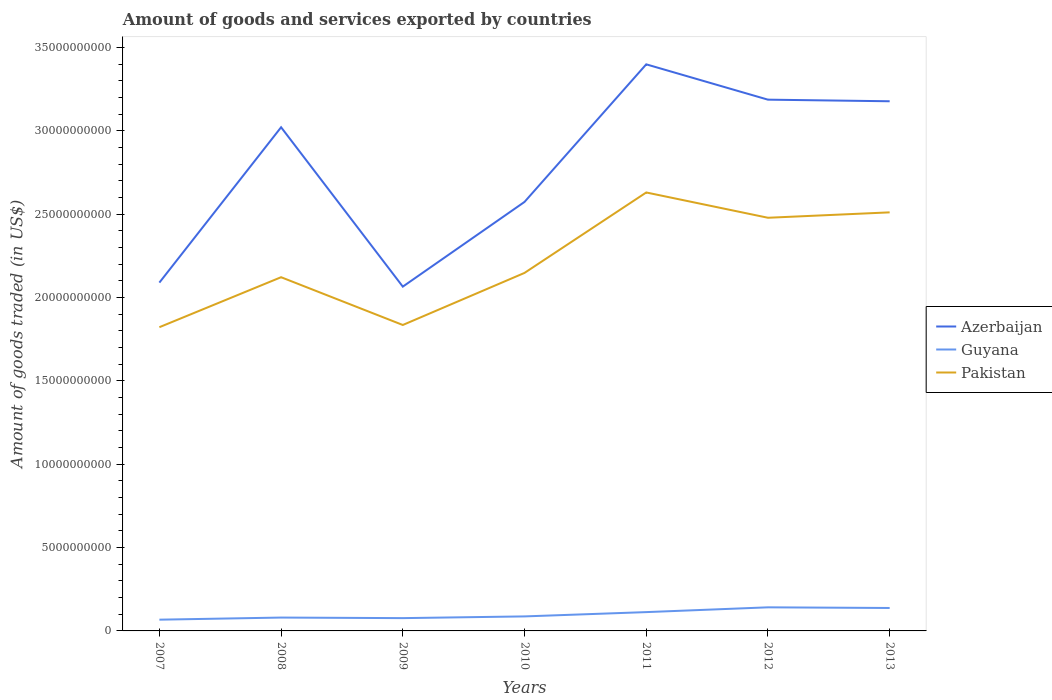Across all years, what is the maximum total amount of goods and services exported in Guyana?
Offer a very short reply. 6.75e+08. What is the total total amount of goods and services exported in Azerbaijan in the graph?
Offer a very short reply. -1.33e+1. What is the difference between the highest and the second highest total amount of goods and services exported in Azerbaijan?
Your answer should be compact. 1.33e+1. How many lines are there?
Keep it short and to the point. 3. What is the difference between two consecutive major ticks on the Y-axis?
Your answer should be very brief. 5.00e+09. Does the graph contain any zero values?
Keep it short and to the point. No. How many legend labels are there?
Your answer should be compact. 3. How are the legend labels stacked?
Your answer should be very brief. Vertical. What is the title of the graph?
Provide a short and direct response. Amount of goods and services exported by countries. Does "Italy" appear as one of the legend labels in the graph?
Give a very brief answer. No. What is the label or title of the X-axis?
Provide a short and direct response. Years. What is the label or title of the Y-axis?
Give a very brief answer. Amount of goods traded (in US$). What is the Amount of goods traded (in US$) of Azerbaijan in 2007?
Make the answer very short. 2.09e+1. What is the Amount of goods traded (in US$) in Guyana in 2007?
Your response must be concise. 6.75e+08. What is the Amount of goods traded (in US$) of Pakistan in 2007?
Your answer should be compact. 1.82e+1. What is the Amount of goods traded (in US$) of Azerbaijan in 2008?
Your answer should be compact. 3.02e+1. What is the Amount of goods traded (in US$) of Guyana in 2008?
Your answer should be compact. 8.02e+08. What is the Amount of goods traded (in US$) in Pakistan in 2008?
Keep it short and to the point. 2.12e+1. What is the Amount of goods traded (in US$) of Azerbaijan in 2009?
Your response must be concise. 2.07e+1. What is the Amount of goods traded (in US$) in Guyana in 2009?
Offer a very short reply. 7.68e+08. What is the Amount of goods traded (in US$) of Pakistan in 2009?
Your response must be concise. 1.84e+1. What is the Amount of goods traded (in US$) of Azerbaijan in 2010?
Your answer should be compact. 2.57e+1. What is the Amount of goods traded (in US$) of Guyana in 2010?
Your response must be concise. 8.71e+08. What is the Amount of goods traded (in US$) in Pakistan in 2010?
Offer a terse response. 2.15e+1. What is the Amount of goods traded (in US$) of Azerbaijan in 2011?
Your answer should be very brief. 3.40e+1. What is the Amount of goods traded (in US$) of Guyana in 2011?
Keep it short and to the point. 1.13e+09. What is the Amount of goods traded (in US$) in Pakistan in 2011?
Your response must be concise. 2.63e+1. What is the Amount of goods traded (in US$) in Azerbaijan in 2012?
Your answer should be compact. 3.19e+1. What is the Amount of goods traded (in US$) in Guyana in 2012?
Offer a terse response. 1.42e+09. What is the Amount of goods traded (in US$) of Pakistan in 2012?
Ensure brevity in your answer.  2.48e+1. What is the Amount of goods traded (in US$) of Azerbaijan in 2013?
Your answer should be compact. 3.18e+1. What is the Amount of goods traded (in US$) of Guyana in 2013?
Your answer should be very brief. 1.38e+09. What is the Amount of goods traded (in US$) of Pakistan in 2013?
Give a very brief answer. 2.51e+1. Across all years, what is the maximum Amount of goods traded (in US$) of Azerbaijan?
Make the answer very short. 3.40e+1. Across all years, what is the maximum Amount of goods traded (in US$) in Guyana?
Provide a short and direct response. 1.42e+09. Across all years, what is the maximum Amount of goods traded (in US$) in Pakistan?
Your answer should be compact. 2.63e+1. Across all years, what is the minimum Amount of goods traded (in US$) in Azerbaijan?
Your answer should be compact. 2.07e+1. Across all years, what is the minimum Amount of goods traded (in US$) in Guyana?
Your response must be concise. 6.75e+08. Across all years, what is the minimum Amount of goods traded (in US$) in Pakistan?
Your answer should be very brief. 1.82e+1. What is the total Amount of goods traded (in US$) of Azerbaijan in the graph?
Ensure brevity in your answer.  1.95e+11. What is the total Amount of goods traded (in US$) in Guyana in the graph?
Give a very brief answer. 7.04e+09. What is the total Amount of goods traded (in US$) of Pakistan in the graph?
Provide a succinct answer. 1.56e+11. What is the difference between the Amount of goods traded (in US$) of Azerbaijan in 2007 and that in 2008?
Keep it short and to the point. -9.32e+09. What is the difference between the Amount of goods traded (in US$) in Guyana in 2007 and that in 2008?
Keep it short and to the point. -1.27e+08. What is the difference between the Amount of goods traded (in US$) of Pakistan in 2007 and that in 2008?
Offer a terse response. -3.00e+09. What is the difference between the Amount of goods traded (in US$) of Azerbaijan in 2007 and that in 2009?
Provide a short and direct response. 2.41e+08. What is the difference between the Amount of goods traded (in US$) of Guyana in 2007 and that in 2009?
Your response must be concise. -9.33e+07. What is the difference between the Amount of goods traded (in US$) in Pakistan in 2007 and that in 2009?
Your answer should be very brief. -1.33e+08. What is the difference between the Amount of goods traded (in US$) of Azerbaijan in 2007 and that in 2010?
Your answer should be compact. -4.84e+09. What is the difference between the Amount of goods traded (in US$) of Guyana in 2007 and that in 2010?
Provide a succinct answer. -1.96e+08. What is the difference between the Amount of goods traded (in US$) in Pakistan in 2007 and that in 2010?
Offer a very short reply. -3.26e+09. What is the difference between the Amount of goods traded (in US$) of Azerbaijan in 2007 and that in 2011?
Give a very brief answer. -1.31e+1. What is the difference between the Amount of goods traded (in US$) in Guyana in 2007 and that in 2011?
Offer a very short reply. -4.54e+08. What is the difference between the Amount of goods traded (in US$) in Pakistan in 2007 and that in 2011?
Your answer should be compact. -8.08e+09. What is the difference between the Amount of goods traded (in US$) in Azerbaijan in 2007 and that in 2012?
Your response must be concise. -1.10e+1. What is the difference between the Amount of goods traded (in US$) in Guyana in 2007 and that in 2012?
Provide a short and direct response. -7.41e+08. What is the difference between the Amount of goods traded (in US$) of Pakistan in 2007 and that in 2012?
Offer a terse response. -6.57e+09. What is the difference between the Amount of goods traded (in US$) in Azerbaijan in 2007 and that in 2013?
Your response must be concise. -1.09e+1. What is the difference between the Amount of goods traded (in US$) of Guyana in 2007 and that in 2013?
Provide a short and direct response. -7.01e+08. What is the difference between the Amount of goods traded (in US$) in Pakistan in 2007 and that in 2013?
Your response must be concise. -6.89e+09. What is the difference between the Amount of goods traded (in US$) in Azerbaijan in 2008 and that in 2009?
Your response must be concise. 9.56e+09. What is the difference between the Amount of goods traded (in US$) of Guyana in 2008 and that in 2009?
Offer a terse response. 3.33e+07. What is the difference between the Amount of goods traded (in US$) in Pakistan in 2008 and that in 2009?
Provide a short and direct response. 2.87e+09. What is the difference between the Amount of goods traded (in US$) of Azerbaijan in 2008 and that in 2010?
Offer a very short reply. 4.48e+09. What is the difference between the Amount of goods traded (in US$) of Guyana in 2008 and that in 2010?
Give a very brief answer. -6.97e+07. What is the difference between the Amount of goods traded (in US$) in Pakistan in 2008 and that in 2010?
Your answer should be compact. -2.58e+08. What is the difference between the Amount of goods traded (in US$) in Azerbaijan in 2008 and that in 2011?
Your answer should be compact. -3.78e+09. What is the difference between the Amount of goods traded (in US$) of Guyana in 2008 and that in 2011?
Make the answer very short. -3.28e+08. What is the difference between the Amount of goods traded (in US$) in Pakistan in 2008 and that in 2011?
Offer a terse response. -5.08e+09. What is the difference between the Amount of goods traded (in US$) in Azerbaijan in 2008 and that in 2012?
Provide a short and direct response. -1.66e+09. What is the difference between the Amount of goods traded (in US$) of Guyana in 2008 and that in 2012?
Ensure brevity in your answer.  -6.14e+08. What is the difference between the Amount of goods traded (in US$) in Pakistan in 2008 and that in 2012?
Provide a succinct answer. -3.57e+09. What is the difference between the Amount of goods traded (in US$) in Azerbaijan in 2008 and that in 2013?
Offer a terse response. -1.56e+09. What is the difference between the Amount of goods traded (in US$) of Guyana in 2008 and that in 2013?
Provide a short and direct response. -5.74e+08. What is the difference between the Amount of goods traded (in US$) in Pakistan in 2008 and that in 2013?
Offer a very short reply. -3.89e+09. What is the difference between the Amount of goods traded (in US$) of Azerbaijan in 2009 and that in 2010?
Offer a very short reply. -5.08e+09. What is the difference between the Amount of goods traded (in US$) in Guyana in 2009 and that in 2010?
Provide a short and direct response. -1.03e+08. What is the difference between the Amount of goods traded (in US$) in Pakistan in 2009 and that in 2010?
Your answer should be very brief. -3.12e+09. What is the difference between the Amount of goods traded (in US$) in Azerbaijan in 2009 and that in 2011?
Your response must be concise. -1.33e+1. What is the difference between the Amount of goods traded (in US$) of Guyana in 2009 and that in 2011?
Your answer should be very brief. -3.61e+08. What is the difference between the Amount of goods traded (in US$) of Pakistan in 2009 and that in 2011?
Your answer should be compact. -7.95e+09. What is the difference between the Amount of goods traded (in US$) of Azerbaijan in 2009 and that in 2012?
Provide a short and direct response. -1.12e+1. What is the difference between the Amount of goods traded (in US$) in Guyana in 2009 and that in 2012?
Your answer should be compact. -6.47e+08. What is the difference between the Amount of goods traded (in US$) of Pakistan in 2009 and that in 2012?
Offer a terse response. -6.43e+09. What is the difference between the Amount of goods traded (in US$) in Azerbaijan in 2009 and that in 2013?
Your response must be concise. -1.11e+1. What is the difference between the Amount of goods traded (in US$) in Guyana in 2009 and that in 2013?
Provide a succinct answer. -6.08e+08. What is the difference between the Amount of goods traded (in US$) of Pakistan in 2009 and that in 2013?
Provide a succinct answer. -6.76e+09. What is the difference between the Amount of goods traded (in US$) of Azerbaijan in 2010 and that in 2011?
Make the answer very short. -8.26e+09. What is the difference between the Amount of goods traded (in US$) in Guyana in 2010 and that in 2011?
Provide a succinct answer. -2.58e+08. What is the difference between the Amount of goods traded (in US$) in Pakistan in 2010 and that in 2011?
Offer a terse response. -4.83e+09. What is the difference between the Amount of goods traded (in US$) of Azerbaijan in 2010 and that in 2012?
Offer a very short reply. -6.14e+09. What is the difference between the Amount of goods traded (in US$) in Guyana in 2010 and that in 2012?
Provide a short and direct response. -5.44e+08. What is the difference between the Amount of goods traded (in US$) of Pakistan in 2010 and that in 2012?
Keep it short and to the point. -3.31e+09. What is the difference between the Amount of goods traded (in US$) in Azerbaijan in 2010 and that in 2013?
Give a very brief answer. -6.04e+09. What is the difference between the Amount of goods traded (in US$) of Guyana in 2010 and that in 2013?
Your answer should be compact. -5.05e+08. What is the difference between the Amount of goods traded (in US$) of Pakistan in 2010 and that in 2013?
Give a very brief answer. -3.63e+09. What is the difference between the Amount of goods traded (in US$) in Azerbaijan in 2011 and that in 2012?
Keep it short and to the point. 2.12e+09. What is the difference between the Amount of goods traded (in US$) in Guyana in 2011 and that in 2012?
Offer a very short reply. -2.86e+08. What is the difference between the Amount of goods traded (in US$) in Pakistan in 2011 and that in 2012?
Provide a succinct answer. 1.52e+09. What is the difference between the Amount of goods traded (in US$) in Azerbaijan in 2011 and that in 2013?
Provide a short and direct response. 2.22e+09. What is the difference between the Amount of goods traded (in US$) of Guyana in 2011 and that in 2013?
Provide a short and direct response. -2.47e+08. What is the difference between the Amount of goods traded (in US$) in Pakistan in 2011 and that in 2013?
Offer a very short reply. 1.19e+09. What is the difference between the Amount of goods traded (in US$) of Azerbaijan in 2012 and that in 2013?
Your answer should be very brief. 9.60e+07. What is the difference between the Amount of goods traded (in US$) of Guyana in 2012 and that in 2013?
Make the answer very short. 3.95e+07. What is the difference between the Amount of goods traded (in US$) in Pakistan in 2012 and that in 2013?
Make the answer very short. -3.24e+08. What is the difference between the Amount of goods traded (in US$) of Azerbaijan in 2007 and the Amount of goods traded (in US$) of Guyana in 2008?
Offer a very short reply. 2.01e+1. What is the difference between the Amount of goods traded (in US$) of Azerbaijan in 2007 and the Amount of goods traded (in US$) of Pakistan in 2008?
Ensure brevity in your answer.  -3.24e+08. What is the difference between the Amount of goods traded (in US$) in Guyana in 2007 and the Amount of goods traded (in US$) in Pakistan in 2008?
Offer a very short reply. -2.05e+1. What is the difference between the Amount of goods traded (in US$) of Azerbaijan in 2007 and the Amount of goods traded (in US$) of Guyana in 2009?
Ensure brevity in your answer.  2.01e+1. What is the difference between the Amount of goods traded (in US$) of Azerbaijan in 2007 and the Amount of goods traded (in US$) of Pakistan in 2009?
Offer a very short reply. 2.54e+09. What is the difference between the Amount of goods traded (in US$) of Guyana in 2007 and the Amount of goods traded (in US$) of Pakistan in 2009?
Provide a succinct answer. -1.77e+1. What is the difference between the Amount of goods traded (in US$) of Azerbaijan in 2007 and the Amount of goods traded (in US$) of Guyana in 2010?
Provide a succinct answer. 2.00e+1. What is the difference between the Amount of goods traded (in US$) in Azerbaijan in 2007 and the Amount of goods traded (in US$) in Pakistan in 2010?
Keep it short and to the point. -5.82e+08. What is the difference between the Amount of goods traded (in US$) of Guyana in 2007 and the Amount of goods traded (in US$) of Pakistan in 2010?
Make the answer very short. -2.08e+1. What is the difference between the Amount of goods traded (in US$) in Azerbaijan in 2007 and the Amount of goods traded (in US$) in Guyana in 2011?
Provide a short and direct response. 1.98e+1. What is the difference between the Amount of goods traded (in US$) in Azerbaijan in 2007 and the Amount of goods traded (in US$) in Pakistan in 2011?
Your response must be concise. -5.41e+09. What is the difference between the Amount of goods traded (in US$) in Guyana in 2007 and the Amount of goods traded (in US$) in Pakistan in 2011?
Your response must be concise. -2.56e+1. What is the difference between the Amount of goods traded (in US$) in Azerbaijan in 2007 and the Amount of goods traded (in US$) in Guyana in 2012?
Provide a succinct answer. 1.95e+1. What is the difference between the Amount of goods traded (in US$) in Azerbaijan in 2007 and the Amount of goods traded (in US$) in Pakistan in 2012?
Your response must be concise. -3.89e+09. What is the difference between the Amount of goods traded (in US$) of Guyana in 2007 and the Amount of goods traded (in US$) of Pakistan in 2012?
Provide a short and direct response. -2.41e+1. What is the difference between the Amount of goods traded (in US$) in Azerbaijan in 2007 and the Amount of goods traded (in US$) in Guyana in 2013?
Provide a succinct answer. 1.95e+1. What is the difference between the Amount of goods traded (in US$) of Azerbaijan in 2007 and the Amount of goods traded (in US$) of Pakistan in 2013?
Give a very brief answer. -4.22e+09. What is the difference between the Amount of goods traded (in US$) of Guyana in 2007 and the Amount of goods traded (in US$) of Pakistan in 2013?
Make the answer very short. -2.44e+1. What is the difference between the Amount of goods traded (in US$) of Azerbaijan in 2008 and the Amount of goods traded (in US$) of Guyana in 2009?
Your answer should be very brief. 2.95e+1. What is the difference between the Amount of goods traded (in US$) in Azerbaijan in 2008 and the Amount of goods traded (in US$) in Pakistan in 2009?
Your answer should be compact. 1.19e+1. What is the difference between the Amount of goods traded (in US$) in Guyana in 2008 and the Amount of goods traded (in US$) in Pakistan in 2009?
Your answer should be very brief. -1.76e+1. What is the difference between the Amount of goods traded (in US$) in Azerbaijan in 2008 and the Amount of goods traded (in US$) in Guyana in 2010?
Your answer should be very brief. 2.93e+1. What is the difference between the Amount of goods traded (in US$) in Azerbaijan in 2008 and the Amount of goods traded (in US$) in Pakistan in 2010?
Provide a short and direct response. 8.74e+09. What is the difference between the Amount of goods traded (in US$) of Guyana in 2008 and the Amount of goods traded (in US$) of Pakistan in 2010?
Offer a very short reply. -2.07e+1. What is the difference between the Amount of goods traded (in US$) in Azerbaijan in 2008 and the Amount of goods traded (in US$) in Guyana in 2011?
Your answer should be very brief. 2.91e+1. What is the difference between the Amount of goods traded (in US$) of Azerbaijan in 2008 and the Amount of goods traded (in US$) of Pakistan in 2011?
Offer a very short reply. 3.91e+09. What is the difference between the Amount of goods traded (in US$) of Guyana in 2008 and the Amount of goods traded (in US$) of Pakistan in 2011?
Keep it short and to the point. -2.55e+1. What is the difference between the Amount of goods traded (in US$) of Azerbaijan in 2008 and the Amount of goods traded (in US$) of Guyana in 2012?
Provide a short and direct response. 2.88e+1. What is the difference between the Amount of goods traded (in US$) in Azerbaijan in 2008 and the Amount of goods traded (in US$) in Pakistan in 2012?
Your answer should be very brief. 5.43e+09. What is the difference between the Amount of goods traded (in US$) in Guyana in 2008 and the Amount of goods traded (in US$) in Pakistan in 2012?
Provide a succinct answer. -2.40e+1. What is the difference between the Amount of goods traded (in US$) in Azerbaijan in 2008 and the Amount of goods traded (in US$) in Guyana in 2013?
Provide a succinct answer. 2.88e+1. What is the difference between the Amount of goods traded (in US$) in Azerbaijan in 2008 and the Amount of goods traded (in US$) in Pakistan in 2013?
Offer a terse response. 5.11e+09. What is the difference between the Amount of goods traded (in US$) of Guyana in 2008 and the Amount of goods traded (in US$) of Pakistan in 2013?
Make the answer very short. -2.43e+1. What is the difference between the Amount of goods traded (in US$) of Azerbaijan in 2009 and the Amount of goods traded (in US$) of Guyana in 2010?
Your answer should be compact. 1.98e+1. What is the difference between the Amount of goods traded (in US$) in Azerbaijan in 2009 and the Amount of goods traded (in US$) in Pakistan in 2010?
Your answer should be very brief. -8.24e+08. What is the difference between the Amount of goods traded (in US$) of Guyana in 2009 and the Amount of goods traded (in US$) of Pakistan in 2010?
Your answer should be very brief. -2.07e+1. What is the difference between the Amount of goods traded (in US$) in Azerbaijan in 2009 and the Amount of goods traded (in US$) in Guyana in 2011?
Provide a succinct answer. 1.95e+1. What is the difference between the Amount of goods traded (in US$) in Azerbaijan in 2009 and the Amount of goods traded (in US$) in Pakistan in 2011?
Offer a very short reply. -5.65e+09. What is the difference between the Amount of goods traded (in US$) of Guyana in 2009 and the Amount of goods traded (in US$) of Pakistan in 2011?
Offer a terse response. -2.55e+1. What is the difference between the Amount of goods traded (in US$) in Azerbaijan in 2009 and the Amount of goods traded (in US$) in Guyana in 2012?
Your response must be concise. 1.92e+1. What is the difference between the Amount of goods traded (in US$) in Azerbaijan in 2009 and the Amount of goods traded (in US$) in Pakistan in 2012?
Keep it short and to the point. -4.13e+09. What is the difference between the Amount of goods traded (in US$) in Guyana in 2009 and the Amount of goods traded (in US$) in Pakistan in 2012?
Your response must be concise. -2.40e+1. What is the difference between the Amount of goods traded (in US$) in Azerbaijan in 2009 and the Amount of goods traded (in US$) in Guyana in 2013?
Offer a very short reply. 1.93e+1. What is the difference between the Amount of goods traded (in US$) in Azerbaijan in 2009 and the Amount of goods traded (in US$) in Pakistan in 2013?
Offer a very short reply. -4.46e+09. What is the difference between the Amount of goods traded (in US$) in Guyana in 2009 and the Amount of goods traded (in US$) in Pakistan in 2013?
Offer a terse response. -2.43e+1. What is the difference between the Amount of goods traded (in US$) in Azerbaijan in 2010 and the Amount of goods traded (in US$) in Guyana in 2011?
Make the answer very short. 2.46e+1. What is the difference between the Amount of goods traded (in US$) in Azerbaijan in 2010 and the Amount of goods traded (in US$) in Pakistan in 2011?
Provide a short and direct response. -5.67e+08. What is the difference between the Amount of goods traded (in US$) of Guyana in 2010 and the Amount of goods traded (in US$) of Pakistan in 2011?
Offer a very short reply. -2.54e+1. What is the difference between the Amount of goods traded (in US$) of Azerbaijan in 2010 and the Amount of goods traded (in US$) of Guyana in 2012?
Ensure brevity in your answer.  2.43e+1. What is the difference between the Amount of goods traded (in US$) in Azerbaijan in 2010 and the Amount of goods traded (in US$) in Pakistan in 2012?
Your answer should be very brief. 9.50e+08. What is the difference between the Amount of goods traded (in US$) of Guyana in 2010 and the Amount of goods traded (in US$) of Pakistan in 2012?
Your answer should be compact. -2.39e+1. What is the difference between the Amount of goods traded (in US$) in Azerbaijan in 2010 and the Amount of goods traded (in US$) in Guyana in 2013?
Keep it short and to the point. 2.44e+1. What is the difference between the Amount of goods traded (in US$) of Azerbaijan in 2010 and the Amount of goods traded (in US$) of Pakistan in 2013?
Your answer should be very brief. 6.26e+08. What is the difference between the Amount of goods traded (in US$) of Guyana in 2010 and the Amount of goods traded (in US$) of Pakistan in 2013?
Your response must be concise. -2.42e+1. What is the difference between the Amount of goods traded (in US$) in Azerbaijan in 2011 and the Amount of goods traded (in US$) in Guyana in 2012?
Provide a short and direct response. 3.26e+1. What is the difference between the Amount of goods traded (in US$) of Azerbaijan in 2011 and the Amount of goods traded (in US$) of Pakistan in 2012?
Make the answer very short. 9.21e+09. What is the difference between the Amount of goods traded (in US$) of Guyana in 2011 and the Amount of goods traded (in US$) of Pakistan in 2012?
Your answer should be compact. -2.37e+1. What is the difference between the Amount of goods traded (in US$) in Azerbaijan in 2011 and the Amount of goods traded (in US$) in Guyana in 2013?
Keep it short and to the point. 3.26e+1. What is the difference between the Amount of goods traded (in US$) in Azerbaijan in 2011 and the Amount of goods traded (in US$) in Pakistan in 2013?
Make the answer very short. 8.88e+09. What is the difference between the Amount of goods traded (in US$) in Guyana in 2011 and the Amount of goods traded (in US$) in Pakistan in 2013?
Your response must be concise. -2.40e+1. What is the difference between the Amount of goods traded (in US$) in Azerbaijan in 2012 and the Amount of goods traded (in US$) in Guyana in 2013?
Ensure brevity in your answer.  3.05e+1. What is the difference between the Amount of goods traded (in US$) of Azerbaijan in 2012 and the Amount of goods traded (in US$) of Pakistan in 2013?
Give a very brief answer. 6.76e+09. What is the difference between the Amount of goods traded (in US$) of Guyana in 2012 and the Amount of goods traded (in US$) of Pakistan in 2013?
Offer a terse response. -2.37e+1. What is the average Amount of goods traded (in US$) of Azerbaijan per year?
Keep it short and to the point. 2.79e+1. What is the average Amount of goods traded (in US$) of Guyana per year?
Offer a very short reply. 1.01e+09. What is the average Amount of goods traded (in US$) in Pakistan per year?
Offer a very short reply. 2.22e+1. In the year 2007, what is the difference between the Amount of goods traded (in US$) of Azerbaijan and Amount of goods traded (in US$) of Guyana?
Provide a short and direct response. 2.02e+1. In the year 2007, what is the difference between the Amount of goods traded (in US$) in Azerbaijan and Amount of goods traded (in US$) in Pakistan?
Offer a very short reply. 2.68e+09. In the year 2007, what is the difference between the Amount of goods traded (in US$) of Guyana and Amount of goods traded (in US$) of Pakistan?
Offer a very short reply. -1.75e+1. In the year 2008, what is the difference between the Amount of goods traded (in US$) of Azerbaijan and Amount of goods traded (in US$) of Guyana?
Make the answer very short. 2.94e+1. In the year 2008, what is the difference between the Amount of goods traded (in US$) of Azerbaijan and Amount of goods traded (in US$) of Pakistan?
Offer a very short reply. 9.00e+09. In the year 2008, what is the difference between the Amount of goods traded (in US$) in Guyana and Amount of goods traded (in US$) in Pakistan?
Your answer should be very brief. -2.04e+1. In the year 2009, what is the difference between the Amount of goods traded (in US$) of Azerbaijan and Amount of goods traded (in US$) of Guyana?
Your answer should be compact. 1.99e+1. In the year 2009, what is the difference between the Amount of goods traded (in US$) in Azerbaijan and Amount of goods traded (in US$) in Pakistan?
Give a very brief answer. 2.30e+09. In the year 2009, what is the difference between the Amount of goods traded (in US$) of Guyana and Amount of goods traded (in US$) of Pakistan?
Give a very brief answer. -1.76e+1. In the year 2010, what is the difference between the Amount of goods traded (in US$) in Azerbaijan and Amount of goods traded (in US$) in Guyana?
Keep it short and to the point. 2.49e+1. In the year 2010, what is the difference between the Amount of goods traded (in US$) of Azerbaijan and Amount of goods traded (in US$) of Pakistan?
Your answer should be very brief. 4.26e+09. In the year 2010, what is the difference between the Amount of goods traded (in US$) of Guyana and Amount of goods traded (in US$) of Pakistan?
Make the answer very short. -2.06e+1. In the year 2011, what is the difference between the Amount of goods traded (in US$) in Azerbaijan and Amount of goods traded (in US$) in Guyana?
Provide a short and direct response. 3.29e+1. In the year 2011, what is the difference between the Amount of goods traded (in US$) in Azerbaijan and Amount of goods traded (in US$) in Pakistan?
Give a very brief answer. 7.69e+09. In the year 2011, what is the difference between the Amount of goods traded (in US$) in Guyana and Amount of goods traded (in US$) in Pakistan?
Provide a succinct answer. -2.52e+1. In the year 2012, what is the difference between the Amount of goods traded (in US$) of Azerbaijan and Amount of goods traded (in US$) of Guyana?
Your answer should be very brief. 3.05e+1. In the year 2012, what is the difference between the Amount of goods traded (in US$) of Azerbaijan and Amount of goods traded (in US$) of Pakistan?
Keep it short and to the point. 7.09e+09. In the year 2012, what is the difference between the Amount of goods traded (in US$) of Guyana and Amount of goods traded (in US$) of Pakistan?
Ensure brevity in your answer.  -2.34e+1. In the year 2013, what is the difference between the Amount of goods traded (in US$) in Azerbaijan and Amount of goods traded (in US$) in Guyana?
Give a very brief answer. 3.04e+1. In the year 2013, what is the difference between the Amount of goods traded (in US$) of Azerbaijan and Amount of goods traded (in US$) of Pakistan?
Provide a short and direct response. 6.67e+09. In the year 2013, what is the difference between the Amount of goods traded (in US$) of Guyana and Amount of goods traded (in US$) of Pakistan?
Ensure brevity in your answer.  -2.37e+1. What is the ratio of the Amount of goods traded (in US$) in Azerbaijan in 2007 to that in 2008?
Offer a very short reply. 0.69. What is the ratio of the Amount of goods traded (in US$) of Guyana in 2007 to that in 2008?
Offer a very short reply. 0.84. What is the ratio of the Amount of goods traded (in US$) in Pakistan in 2007 to that in 2008?
Give a very brief answer. 0.86. What is the ratio of the Amount of goods traded (in US$) in Azerbaijan in 2007 to that in 2009?
Make the answer very short. 1.01. What is the ratio of the Amount of goods traded (in US$) of Guyana in 2007 to that in 2009?
Provide a short and direct response. 0.88. What is the ratio of the Amount of goods traded (in US$) in Azerbaijan in 2007 to that in 2010?
Make the answer very short. 0.81. What is the ratio of the Amount of goods traded (in US$) of Guyana in 2007 to that in 2010?
Offer a terse response. 0.77. What is the ratio of the Amount of goods traded (in US$) of Pakistan in 2007 to that in 2010?
Make the answer very short. 0.85. What is the ratio of the Amount of goods traded (in US$) in Azerbaijan in 2007 to that in 2011?
Ensure brevity in your answer.  0.61. What is the ratio of the Amount of goods traded (in US$) of Guyana in 2007 to that in 2011?
Keep it short and to the point. 0.6. What is the ratio of the Amount of goods traded (in US$) of Pakistan in 2007 to that in 2011?
Provide a short and direct response. 0.69. What is the ratio of the Amount of goods traded (in US$) in Azerbaijan in 2007 to that in 2012?
Provide a short and direct response. 0.66. What is the ratio of the Amount of goods traded (in US$) in Guyana in 2007 to that in 2012?
Your answer should be very brief. 0.48. What is the ratio of the Amount of goods traded (in US$) in Pakistan in 2007 to that in 2012?
Your answer should be compact. 0.74. What is the ratio of the Amount of goods traded (in US$) of Azerbaijan in 2007 to that in 2013?
Ensure brevity in your answer.  0.66. What is the ratio of the Amount of goods traded (in US$) of Guyana in 2007 to that in 2013?
Your response must be concise. 0.49. What is the ratio of the Amount of goods traded (in US$) of Pakistan in 2007 to that in 2013?
Your answer should be very brief. 0.73. What is the ratio of the Amount of goods traded (in US$) in Azerbaijan in 2008 to that in 2009?
Offer a terse response. 1.46. What is the ratio of the Amount of goods traded (in US$) in Guyana in 2008 to that in 2009?
Give a very brief answer. 1.04. What is the ratio of the Amount of goods traded (in US$) in Pakistan in 2008 to that in 2009?
Keep it short and to the point. 1.16. What is the ratio of the Amount of goods traded (in US$) in Azerbaijan in 2008 to that in 2010?
Make the answer very short. 1.17. What is the ratio of the Amount of goods traded (in US$) of Guyana in 2008 to that in 2010?
Keep it short and to the point. 0.92. What is the ratio of the Amount of goods traded (in US$) of Pakistan in 2008 to that in 2010?
Your answer should be compact. 0.99. What is the ratio of the Amount of goods traded (in US$) in Guyana in 2008 to that in 2011?
Make the answer very short. 0.71. What is the ratio of the Amount of goods traded (in US$) of Pakistan in 2008 to that in 2011?
Make the answer very short. 0.81. What is the ratio of the Amount of goods traded (in US$) in Azerbaijan in 2008 to that in 2012?
Keep it short and to the point. 0.95. What is the ratio of the Amount of goods traded (in US$) of Guyana in 2008 to that in 2012?
Provide a succinct answer. 0.57. What is the ratio of the Amount of goods traded (in US$) of Pakistan in 2008 to that in 2012?
Give a very brief answer. 0.86. What is the ratio of the Amount of goods traded (in US$) of Azerbaijan in 2008 to that in 2013?
Make the answer very short. 0.95. What is the ratio of the Amount of goods traded (in US$) of Guyana in 2008 to that in 2013?
Provide a succinct answer. 0.58. What is the ratio of the Amount of goods traded (in US$) in Pakistan in 2008 to that in 2013?
Make the answer very short. 0.85. What is the ratio of the Amount of goods traded (in US$) of Azerbaijan in 2009 to that in 2010?
Your answer should be very brief. 0.8. What is the ratio of the Amount of goods traded (in US$) in Guyana in 2009 to that in 2010?
Provide a succinct answer. 0.88. What is the ratio of the Amount of goods traded (in US$) in Pakistan in 2009 to that in 2010?
Offer a very short reply. 0.85. What is the ratio of the Amount of goods traded (in US$) in Azerbaijan in 2009 to that in 2011?
Give a very brief answer. 0.61. What is the ratio of the Amount of goods traded (in US$) of Guyana in 2009 to that in 2011?
Offer a terse response. 0.68. What is the ratio of the Amount of goods traded (in US$) of Pakistan in 2009 to that in 2011?
Offer a very short reply. 0.7. What is the ratio of the Amount of goods traded (in US$) in Azerbaijan in 2009 to that in 2012?
Make the answer very short. 0.65. What is the ratio of the Amount of goods traded (in US$) of Guyana in 2009 to that in 2012?
Your answer should be very brief. 0.54. What is the ratio of the Amount of goods traded (in US$) of Pakistan in 2009 to that in 2012?
Your response must be concise. 0.74. What is the ratio of the Amount of goods traded (in US$) of Azerbaijan in 2009 to that in 2013?
Ensure brevity in your answer.  0.65. What is the ratio of the Amount of goods traded (in US$) of Guyana in 2009 to that in 2013?
Offer a terse response. 0.56. What is the ratio of the Amount of goods traded (in US$) in Pakistan in 2009 to that in 2013?
Offer a very short reply. 0.73. What is the ratio of the Amount of goods traded (in US$) of Azerbaijan in 2010 to that in 2011?
Provide a succinct answer. 0.76. What is the ratio of the Amount of goods traded (in US$) in Guyana in 2010 to that in 2011?
Offer a terse response. 0.77. What is the ratio of the Amount of goods traded (in US$) in Pakistan in 2010 to that in 2011?
Provide a short and direct response. 0.82. What is the ratio of the Amount of goods traded (in US$) of Azerbaijan in 2010 to that in 2012?
Give a very brief answer. 0.81. What is the ratio of the Amount of goods traded (in US$) in Guyana in 2010 to that in 2012?
Ensure brevity in your answer.  0.62. What is the ratio of the Amount of goods traded (in US$) in Pakistan in 2010 to that in 2012?
Ensure brevity in your answer.  0.87. What is the ratio of the Amount of goods traded (in US$) of Azerbaijan in 2010 to that in 2013?
Your answer should be compact. 0.81. What is the ratio of the Amount of goods traded (in US$) of Guyana in 2010 to that in 2013?
Provide a succinct answer. 0.63. What is the ratio of the Amount of goods traded (in US$) of Pakistan in 2010 to that in 2013?
Ensure brevity in your answer.  0.86. What is the ratio of the Amount of goods traded (in US$) of Azerbaijan in 2011 to that in 2012?
Your answer should be very brief. 1.07. What is the ratio of the Amount of goods traded (in US$) in Guyana in 2011 to that in 2012?
Your answer should be compact. 0.8. What is the ratio of the Amount of goods traded (in US$) of Pakistan in 2011 to that in 2012?
Give a very brief answer. 1.06. What is the ratio of the Amount of goods traded (in US$) in Azerbaijan in 2011 to that in 2013?
Offer a terse response. 1.07. What is the ratio of the Amount of goods traded (in US$) in Guyana in 2011 to that in 2013?
Keep it short and to the point. 0.82. What is the ratio of the Amount of goods traded (in US$) of Pakistan in 2011 to that in 2013?
Keep it short and to the point. 1.05. What is the ratio of the Amount of goods traded (in US$) in Azerbaijan in 2012 to that in 2013?
Your response must be concise. 1. What is the ratio of the Amount of goods traded (in US$) in Guyana in 2012 to that in 2013?
Offer a very short reply. 1.03. What is the ratio of the Amount of goods traded (in US$) of Pakistan in 2012 to that in 2013?
Provide a succinct answer. 0.99. What is the difference between the highest and the second highest Amount of goods traded (in US$) of Azerbaijan?
Provide a short and direct response. 2.12e+09. What is the difference between the highest and the second highest Amount of goods traded (in US$) of Guyana?
Your answer should be very brief. 3.95e+07. What is the difference between the highest and the second highest Amount of goods traded (in US$) of Pakistan?
Your answer should be compact. 1.19e+09. What is the difference between the highest and the lowest Amount of goods traded (in US$) in Azerbaijan?
Provide a succinct answer. 1.33e+1. What is the difference between the highest and the lowest Amount of goods traded (in US$) in Guyana?
Offer a terse response. 7.41e+08. What is the difference between the highest and the lowest Amount of goods traded (in US$) in Pakistan?
Provide a succinct answer. 8.08e+09. 